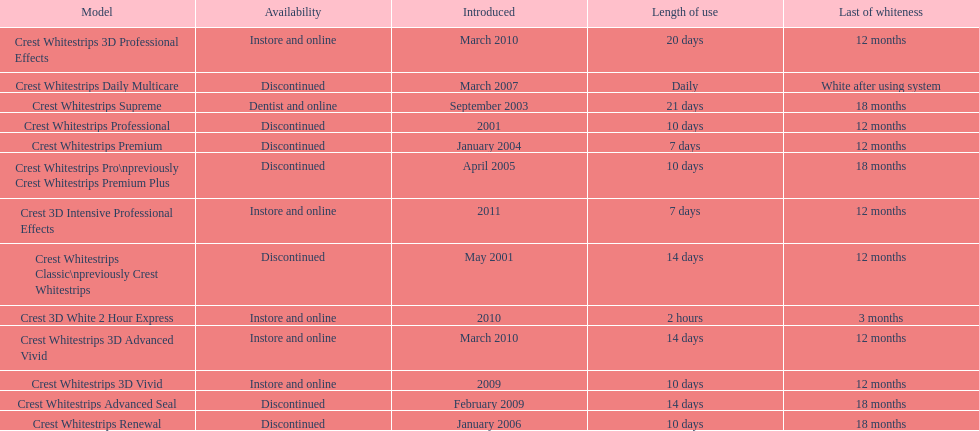Does the crest white strips pro last as long as the crest white strips renewal? Yes. 